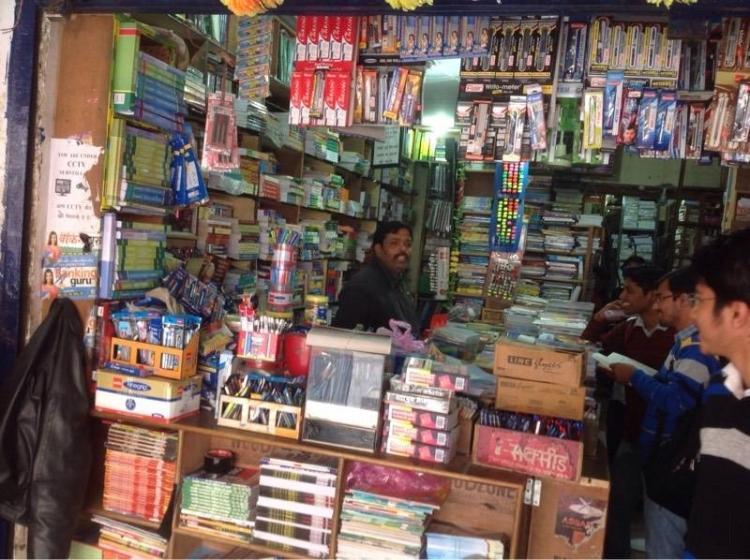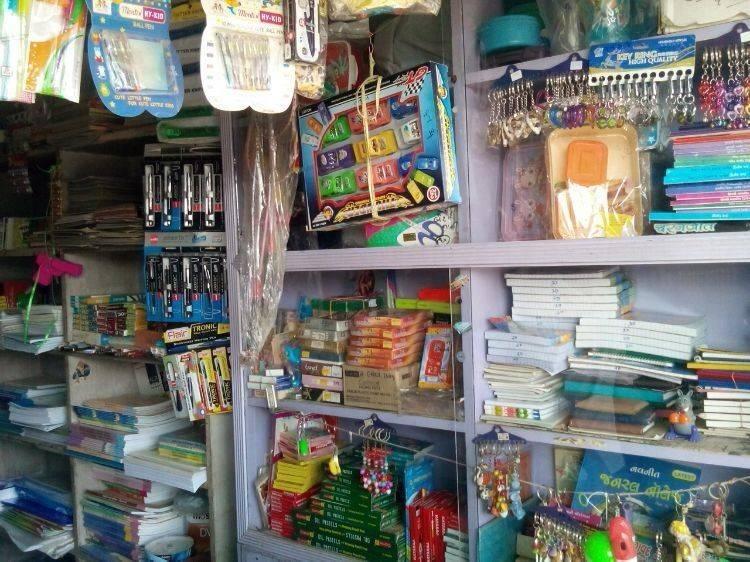The first image is the image on the left, the second image is the image on the right. Examine the images to the left and right. Is the description "All of the people in the shop are men." accurate? Answer yes or no. Yes. The first image is the image on the left, the second image is the image on the right. Given the left and right images, does the statement "All people are standing." hold true? Answer yes or no. Yes. 